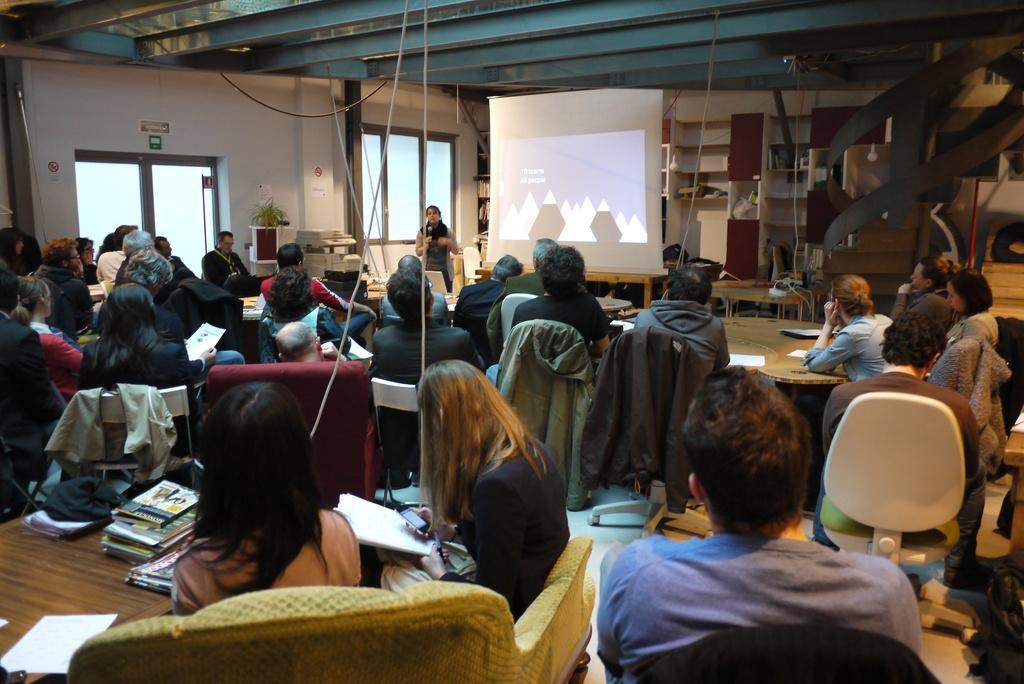Please provide a concise description of this image. In this picture we can see some persons sitting on the chairs. This is the table. On the table there are some books. Here we can see a person who is standing on the floor. And this is the wall. Here we can see a screen and this is the door. On the background we can see a rack. 